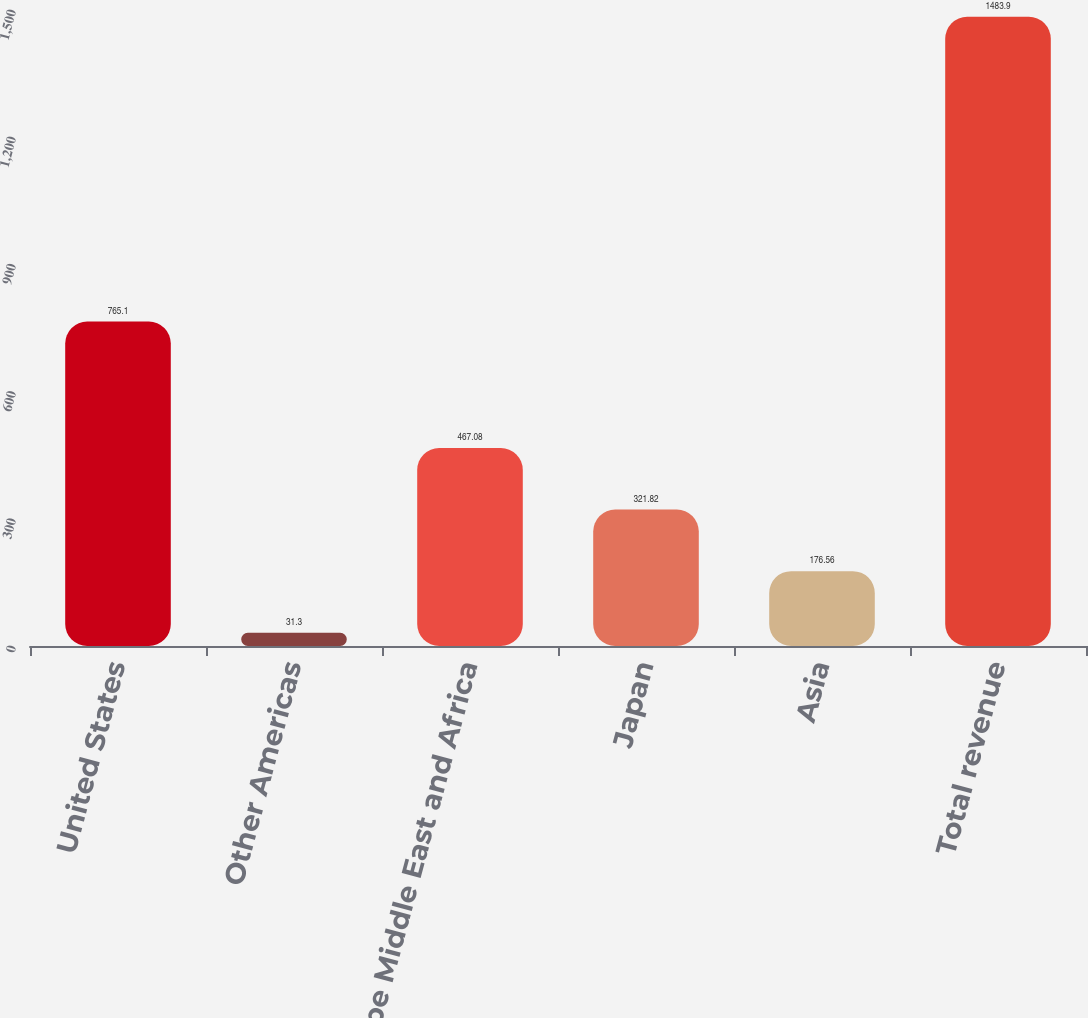<chart> <loc_0><loc_0><loc_500><loc_500><bar_chart><fcel>United States<fcel>Other Americas<fcel>Europe Middle East and Africa<fcel>Japan<fcel>Asia<fcel>Total revenue<nl><fcel>765.1<fcel>31.3<fcel>467.08<fcel>321.82<fcel>176.56<fcel>1483.9<nl></chart> 